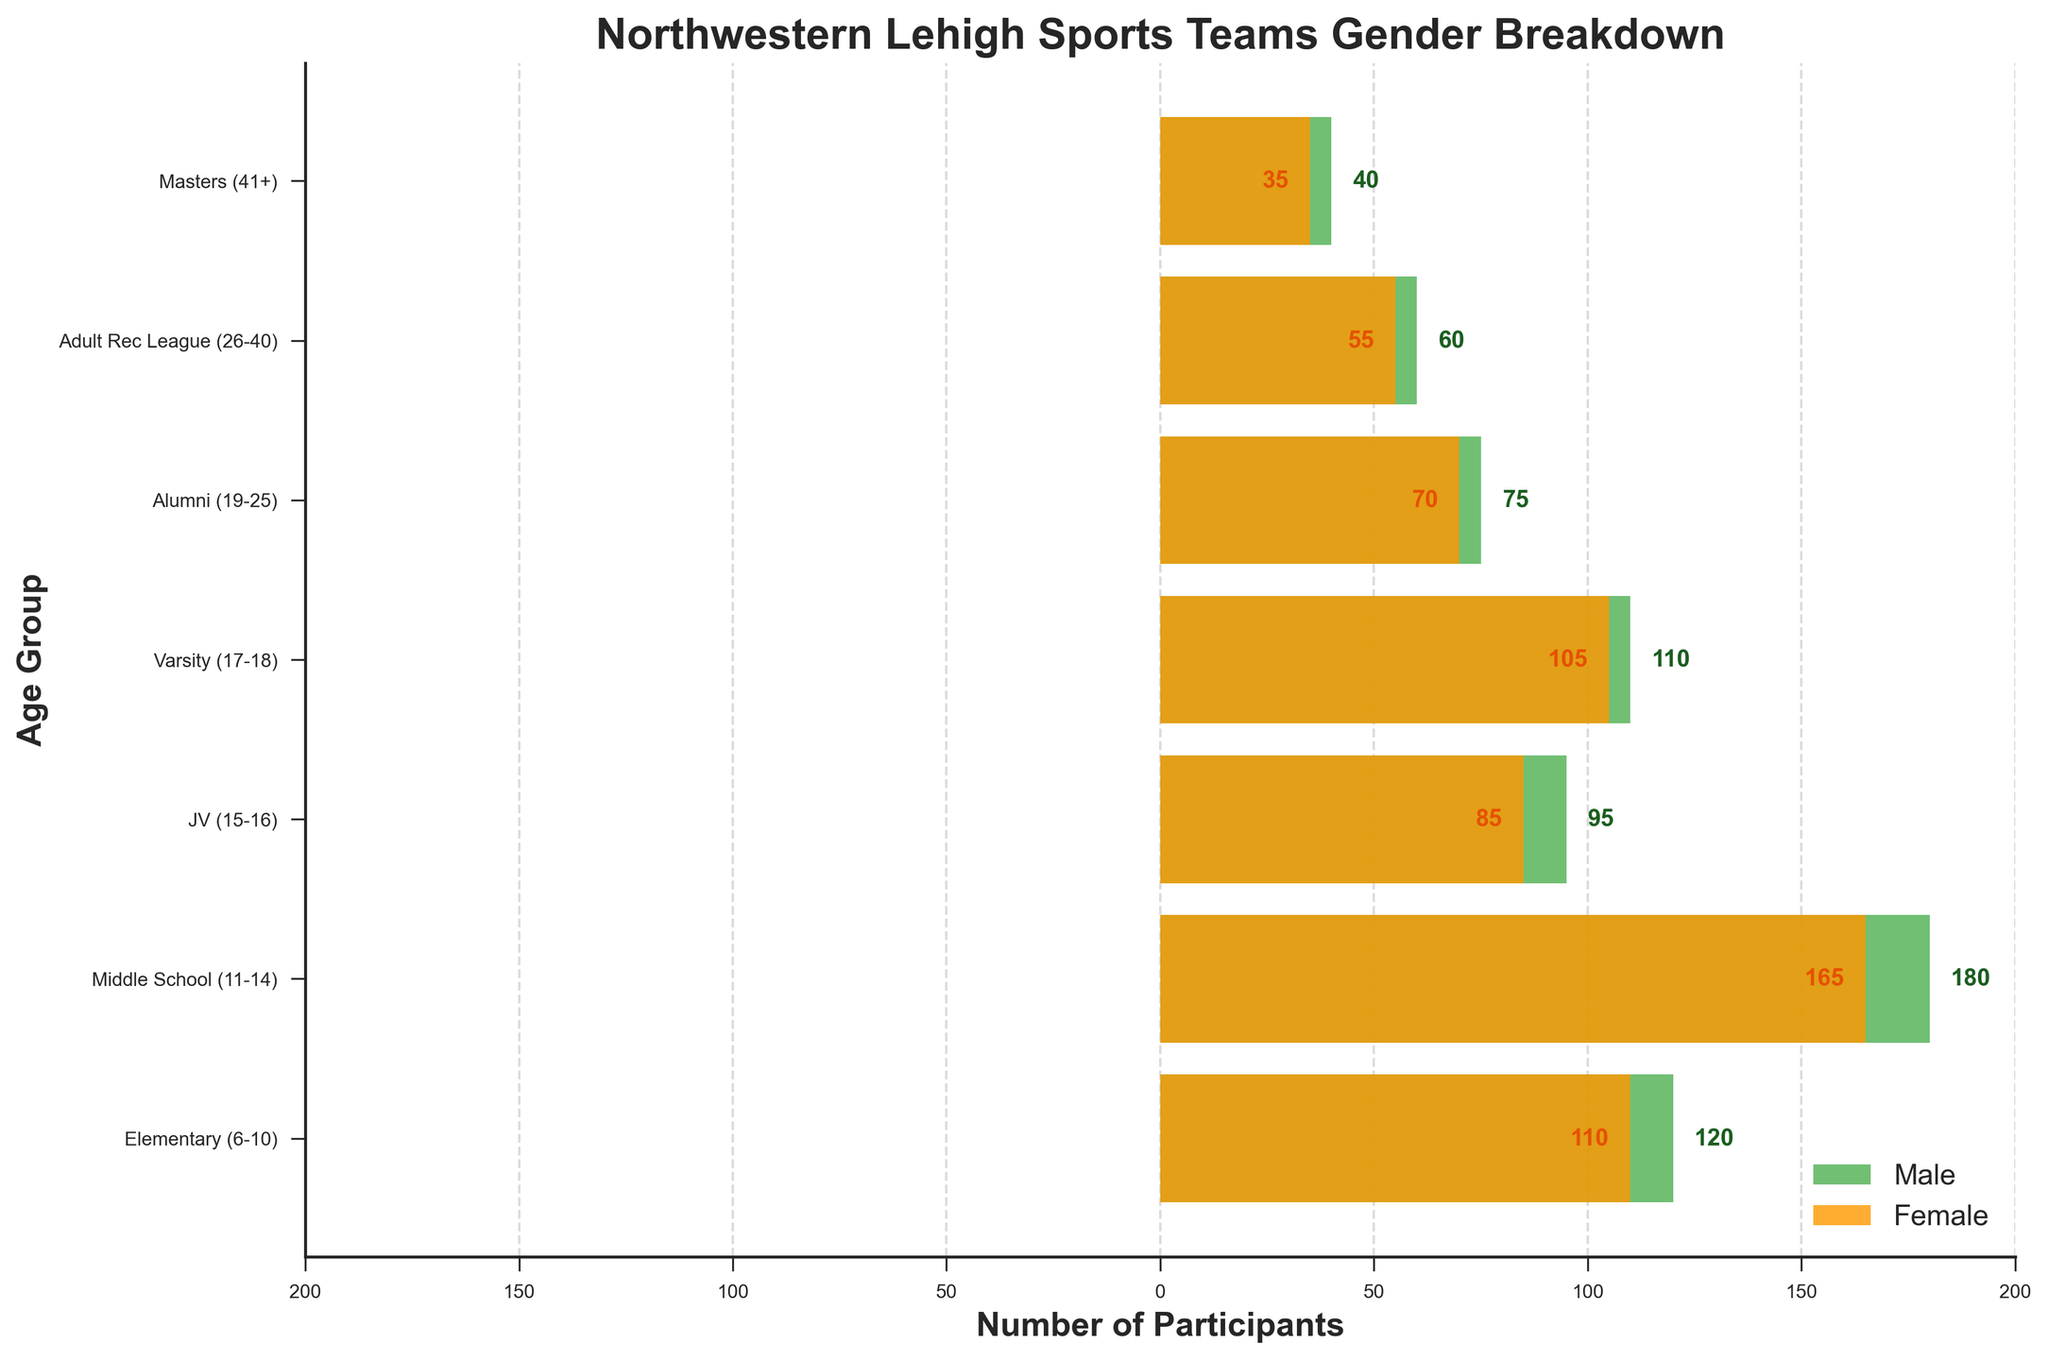Which age group has the highest number of male participants? By examining the figure, we can see that the Middle School (11-14) group has the longest bar in the male (green) section.
Answer: Middle School (11-14) What's the total number of female participants in the Elementary, Middle School, and JV age groups combined? Add the corresponding values from the female (orange) section of the figure: Elementary (110) + Middle School (165) + JV (85) = 360.
Answer: 360 How does the number of male participants in the JV (15-16) group compare to the number of female participants in the same group? From the figure, the JV male participants are 95, while the female participants are 85. Comparing these two values, males have slightly more participants.
Answer: Males have 10 more What percentage of total participants in the Varsity (17-18) age group are female? First, find the total participants in the Varsity group by summing males and females: 110 (males) + 105 (females) = 215. Then, calculate the percentage of females: 105 / 215 ≈ 0.488, which is approximately 48.8%.
Answer: 48.8% Which age group has the smallest difference in the number of male and female participants? For each age group, calculate the absolute difference between males and females: Elementary (10), Middle School (15), JV (10), Varsity (5), Alumni (5), Adult Rec League (5), Masters (5). The smallest differences (5) are observed in the Varsity, Alumni, Adult Rec League, and Masters groups.
Answer: Varsity, Alumni, Adult Rec League, and Masters What is the combined number of participants (both male and female) in the Adult Rec League (26-40) age group? Sum the participants of both genders: 60 (males) + 55 (females) = 115.
Answer: 115 Which age group has a higher female-to-male ratio, Elementary (6-10) or Middle School (11-14)? Calculate the female-to-male ratio for both groups: Elementary ratio = 110 / 120 ≈ 0.917, Middle School ratio = 165 / 180 ≈ 0.917. Both ratios are approximately the same.
Answer: Both In which age group do males constitute roughly half the participants? Compare the number of males to the total number of participants in each group, looking for a ratio close to 0.5. The closest is in the Varsity group: 110 (males) / 215 (total) ≈ 0.511.
Answer: Varsity 